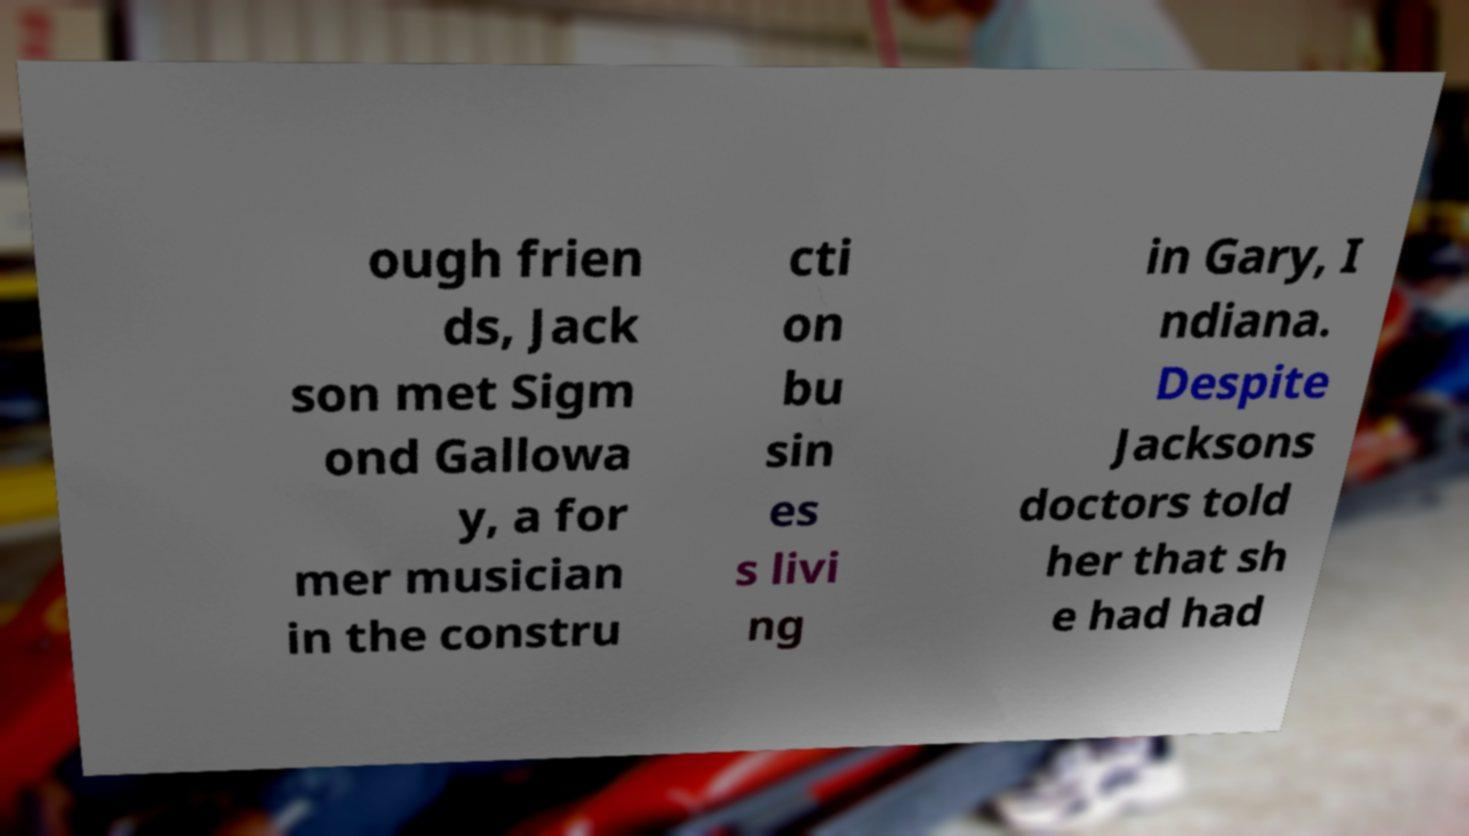Could you assist in decoding the text presented in this image and type it out clearly? ough frien ds, Jack son met Sigm ond Gallowa y, a for mer musician in the constru cti on bu sin es s livi ng in Gary, I ndiana. Despite Jacksons doctors told her that sh e had had 